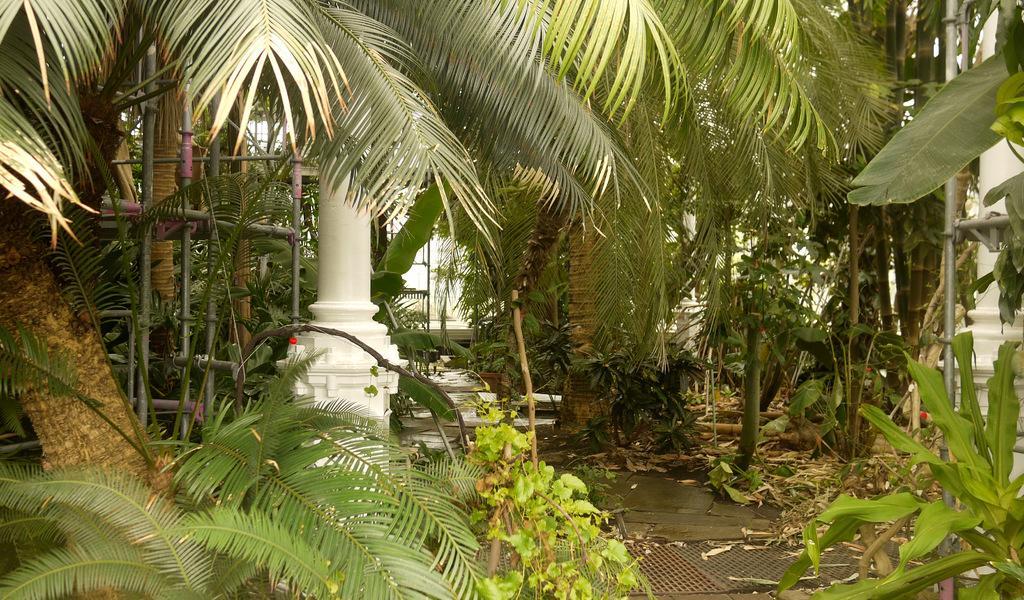How would you summarize this image in a sentence or two? In the foreground of the picture there are plants, trees, pole and an iron frame. In the center of the picture there are dry leaves, trees, iron frame and other objects. In the background there are trees, wall painted white and ladder. 